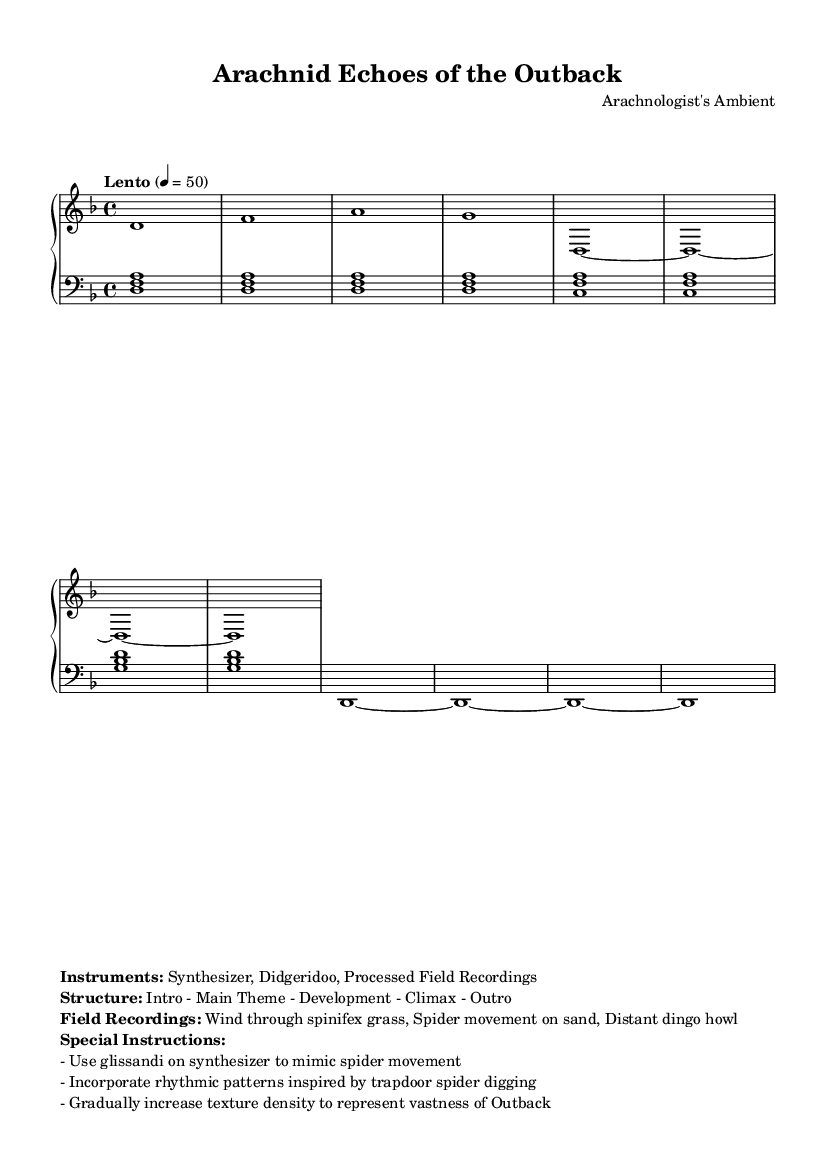What is the time signature of this piece? The time signature is indicated at the beginning of the staff, where it is shown as 4/4. This means there are four beats per measure, with a quarter note receiving one beat.
Answer: 4/4 What is the key signature of this music? The key signature is shown next to the clef at the beginning of the staff, where it has one flat, indicating it is in D minor. The presence of the flat on the B line signifies the key.
Answer: D minor What is the tempo marking for this composition? The tempo marking is displayed above the staff, where it is indicated as "Lento" with a metronome marking of 50 beats per minute. This indicates the piece should be played slowly.
Answer: Lento Which instruments are used in this piece? The instruments are listed in the markup section of the score, where it states "Synthesizer, Didgeridoo, Processed Field Recordings." This gives a clear indication of the instrumentation for the piece.
Answer: Synthesizer, Didgeridoo, Processed Field Recordings What rhythmic pattern is indicated for spider movement? The special instructions section mentions using rhythmic patterns inspired by trapdoor spider digging. This suggests that there is a significant influence of these patterns on the composition’s rhythmic structure.
Answer: Trapdoor spider digging What is the structure of the composition? The structure is outlined in the markup section, which states the order of sections as "Intro - Main Theme - Development - Climax - Outro." This provides a clear roadmap for the piece’s overall layout.
Answer: Intro - Main Theme - Development - Climax - Outro How should the synthesizer emulate spider movement? The special instructions specify using glissandi on the synthesizer to mimic spider movement. This indicates the technique required for achieving the desired sound quality associated with this imagery.
Answer: Glissandi 